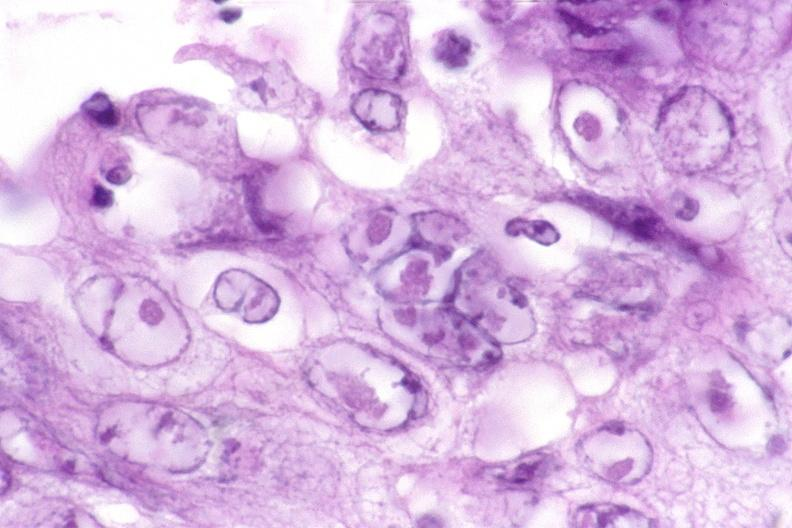does focal hemorrhagic infarction well shown show esophagus, herpes ulcers with inclusion bodies?
Answer the question using a single word or phrase. No 